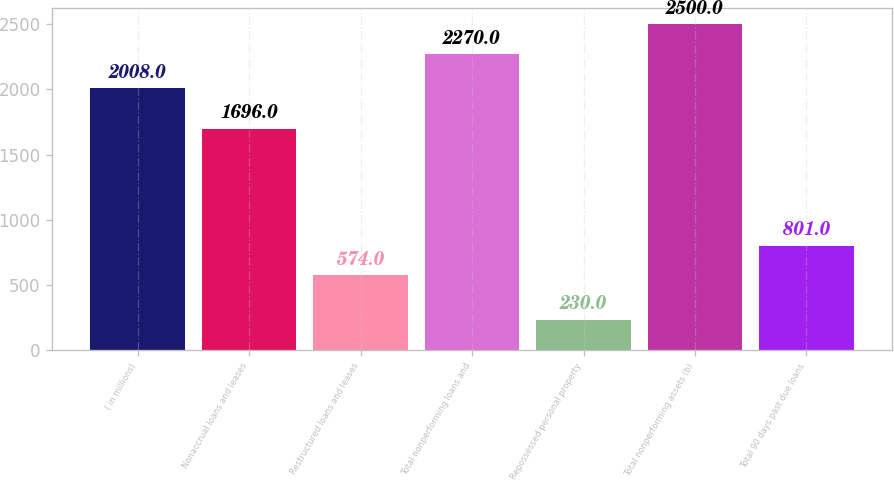<chart> <loc_0><loc_0><loc_500><loc_500><bar_chart><fcel>( in millions)<fcel>Nonaccrual loans and leases<fcel>Restructured loans and leases<fcel>Total nonperforming loans and<fcel>Repossessed personal property<fcel>Total nonperforming assets (b)<fcel>Total 90 days past due loans<nl><fcel>2008<fcel>1696<fcel>574<fcel>2270<fcel>230<fcel>2500<fcel>801<nl></chart> 